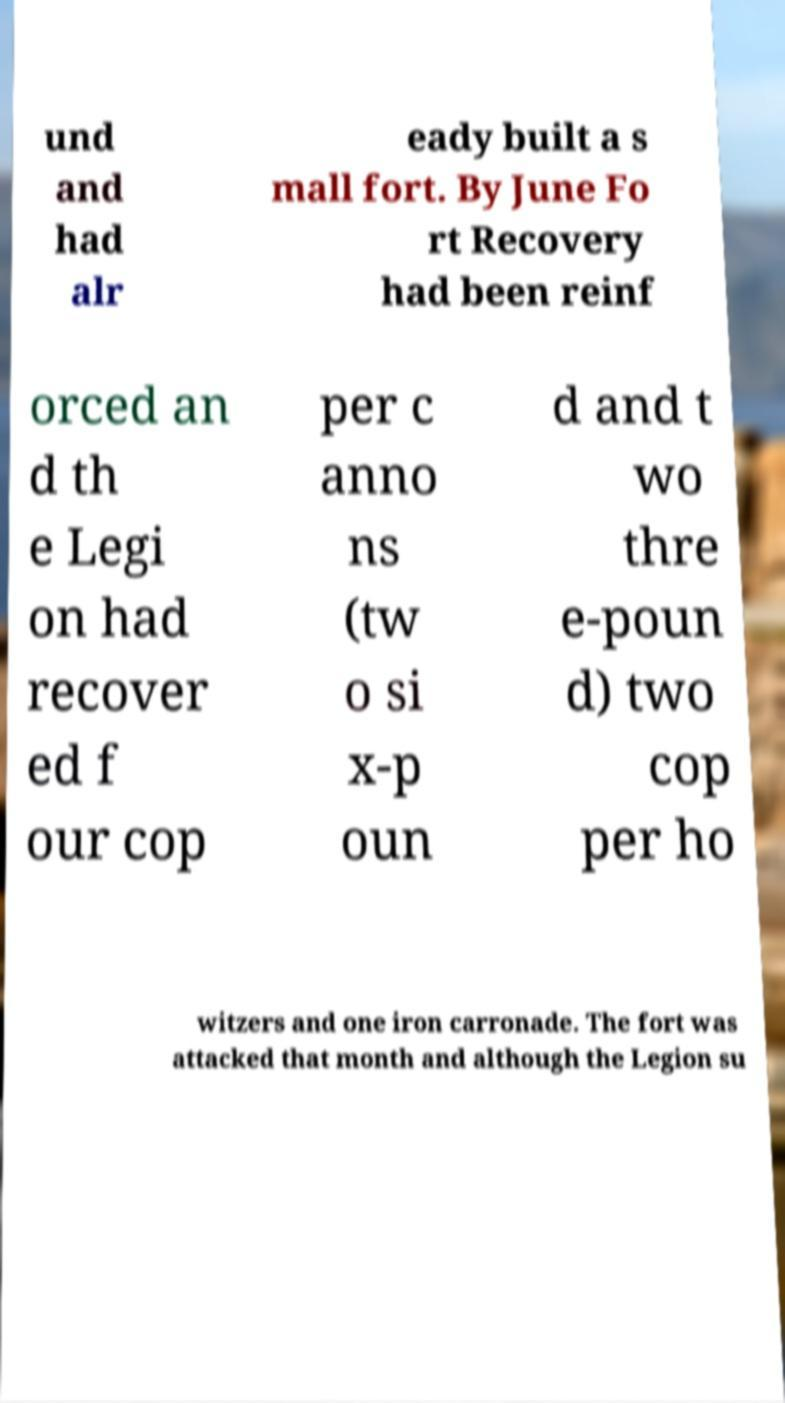Could you extract and type out the text from this image? und and had alr eady built a s mall fort. By June Fo rt Recovery had been reinf orced an d th e Legi on had recover ed f our cop per c anno ns (tw o si x-p oun d and t wo thre e-poun d) two cop per ho witzers and one iron carronade. The fort was attacked that month and although the Legion su 